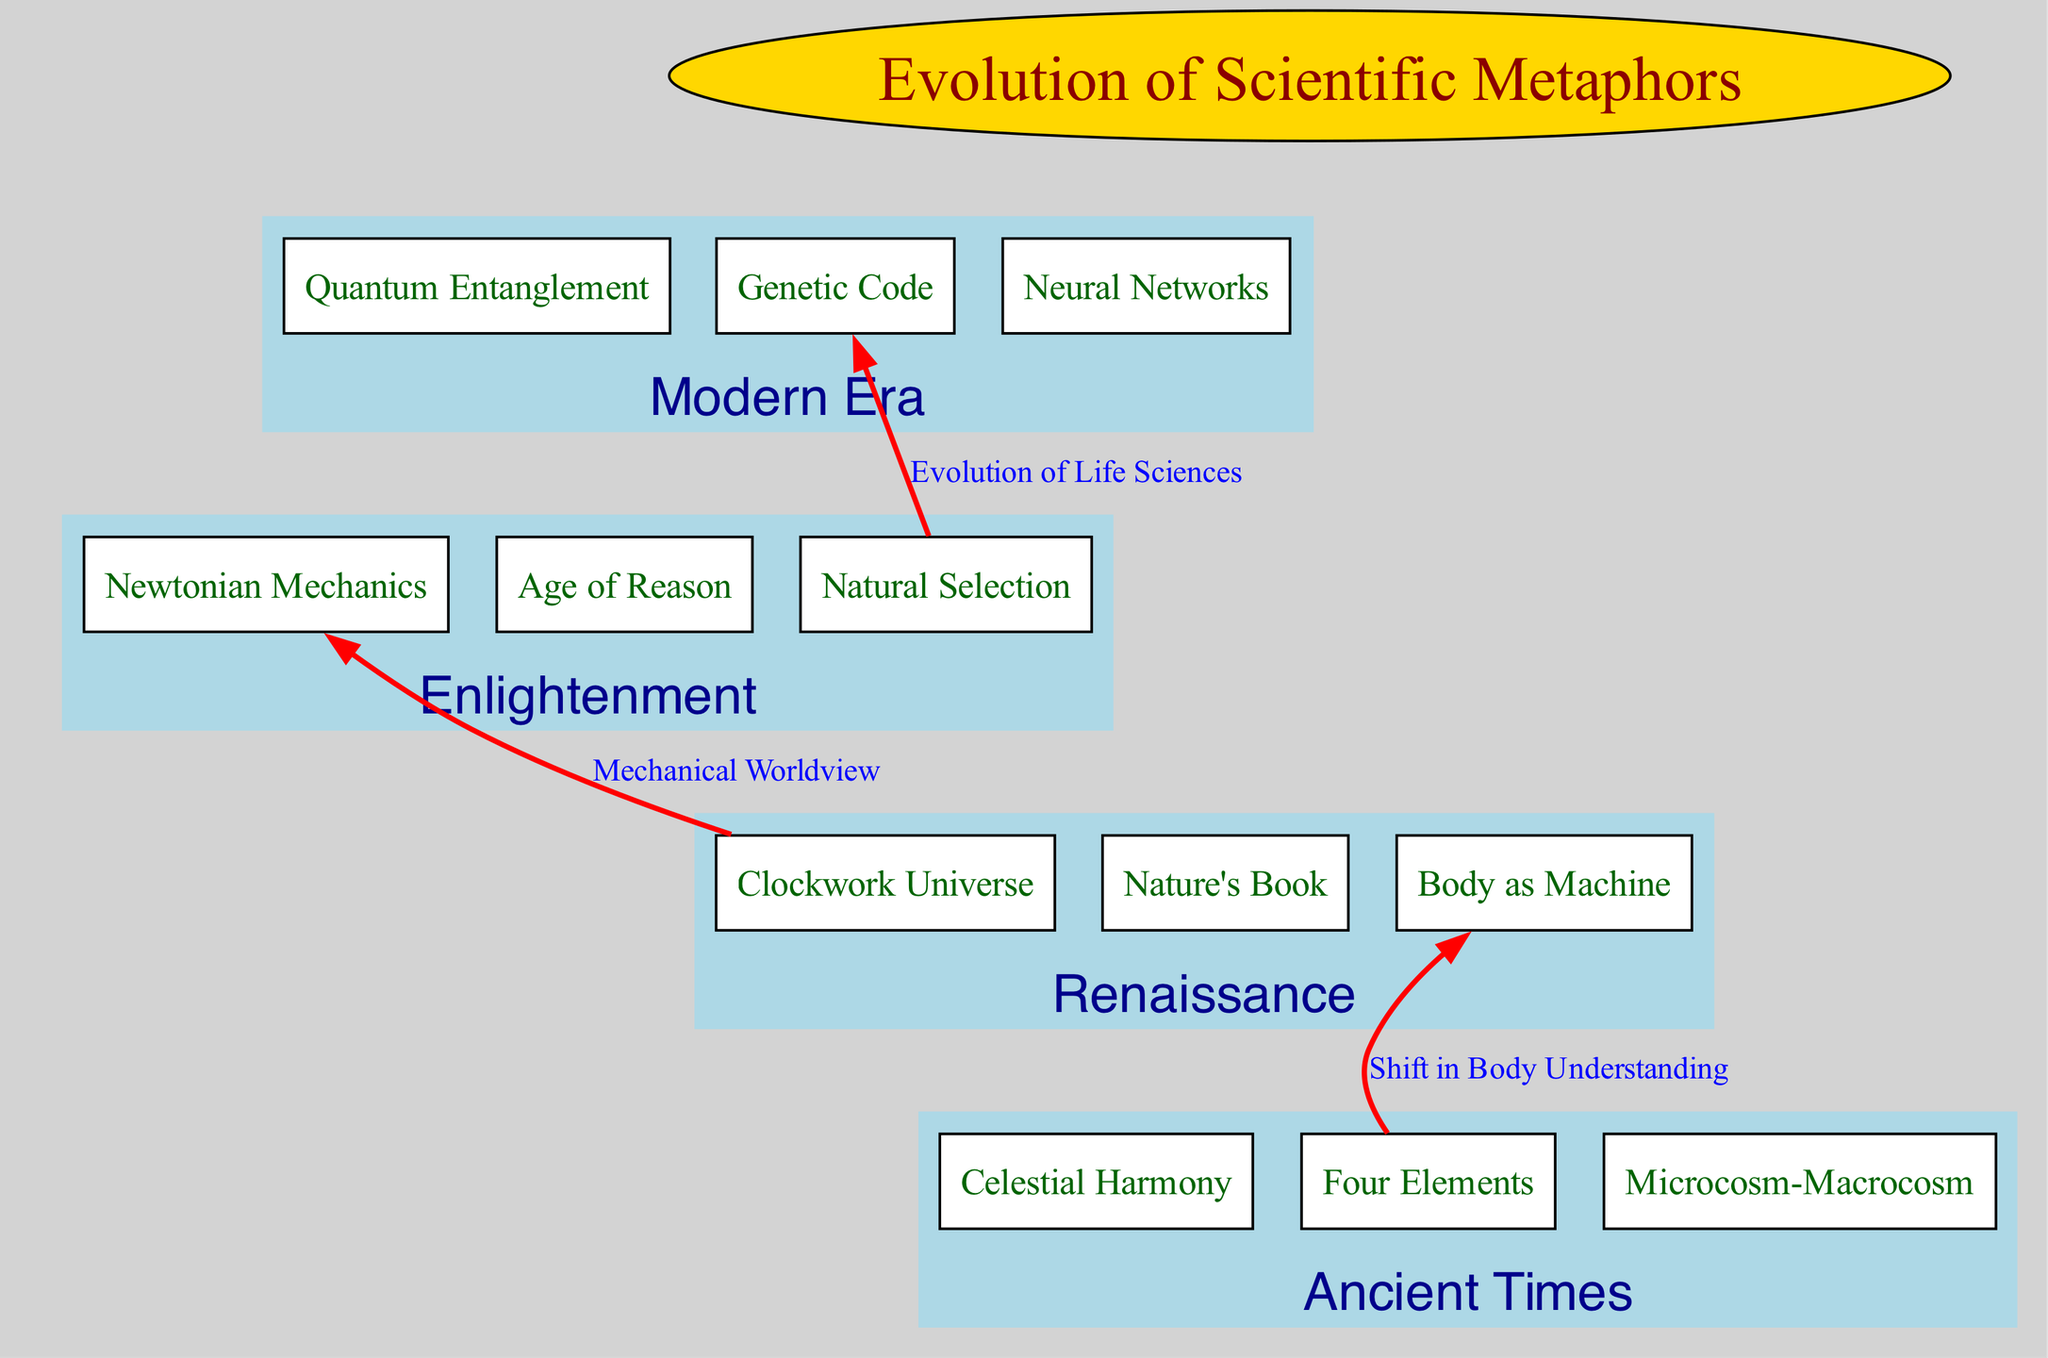What is the root of the diagram? The root node of the diagram is 'Evolution of Scientific Metaphors', which represents the overarching theme of the flow chart.
Answer: Evolution of Scientific Metaphors How many branches are there in the diagram? There are four branches in the diagram, each representing a distinct era in the evolution of scientific metaphors: Ancient Times, Renaissance, Enlightenment, and Modern Era.
Answer: 4 Which metaphor represents the transition from Ancient Times to the Renaissance? The connection between 'Four Elements' and 'Body as Machine' signifies a shift in understanding the human body, transitioning from ancient views to a mechanistic perspective in the Renaissance.
Answer: Body as Machine What metaphor signifies the evolution of life sciences? The connecting edge labeled 'Evolution of Life Sciences' indicates the relationship between 'Natural Selection' from the Enlightenment and 'Genetic Code' from the Modern Era, highlighting the progression in understanding biological processes.
Answer: Genetic Code What represents the mechanical worldview in the diagram? The edge labeled 'Mechanical Worldview' connects 'Clockwork Universe' from the Renaissance to 'Newtonian Mechanics' from the Enlightenment, indicating the shift towards a more mechanical understanding of the universe.
Answer: Newtonian Mechanics Which era's metaphor is associated with 'Quantum Entanglement'? The metaphor 'Quantum Entanglement' is associated with the Modern Era, as it represents contemporary concepts in physics that evolved from earlier understandings of the universe.
Answer: Modern Era What is the connection between 'Clockwork Universe' and 'Natural Selection'? There is no direct connection between 'Clockwork Universe' and 'Natural Selection'; however, both metaphors belong to different eras: the Renaissance and the Enlightenment, respectively, showcasing the progression in metaphorical understanding.
Answer: No connection How many elements are present in the Renaissance branch? The Renaissance branch contains three elements: 'Clockwork Universe', 'Nature's Book', and 'Body as Machine', each representing a metaphor prevalent during that era.
Answer: 3 What do the color coding and shapes of the nodes indicate in the diagram? The shapes of the nodes are boxes for elements and an ellipse for the root, while color coding denotes different branches and relationships, enhancing visual distinction and comprehension of the flow chart.
Answer: Shapes and colors indicate structural hierarchy and categories 